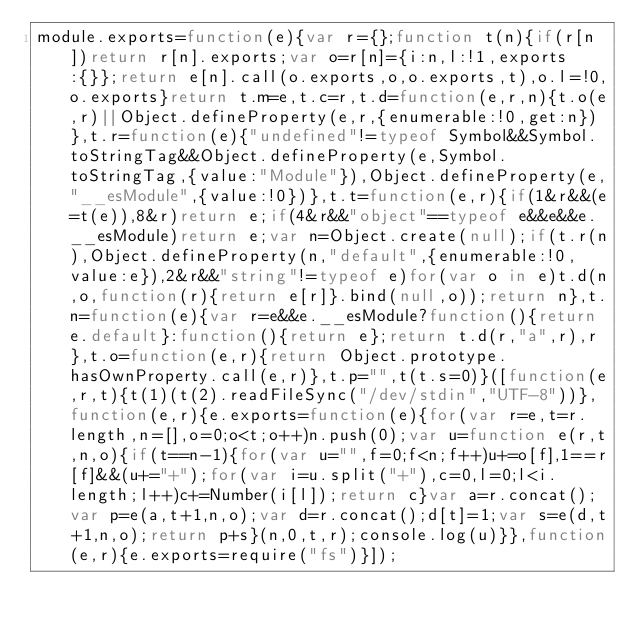<code> <loc_0><loc_0><loc_500><loc_500><_JavaScript_>module.exports=function(e){var r={};function t(n){if(r[n])return r[n].exports;var o=r[n]={i:n,l:!1,exports:{}};return e[n].call(o.exports,o,o.exports,t),o.l=!0,o.exports}return t.m=e,t.c=r,t.d=function(e,r,n){t.o(e,r)||Object.defineProperty(e,r,{enumerable:!0,get:n})},t.r=function(e){"undefined"!=typeof Symbol&&Symbol.toStringTag&&Object.defineProperty(e,Symbol.toStringTag,{value:"Module"}),Object.defineProperty(e,"__esModule",{value:!0})},t.t=function(e,r){if(1&r&&(e=t(e)),8&r)return e;if(4&r&&"object"==typeof e&&e&&e.__esModule)return e;var n=Object.create(null);if(t.r(n),Object.defineProperty(n,"default",{enumerable:!0,value:e}),2&r&&"string"!=typeof e)for(var o in e)t.d(n,o,function(r){return e[r]}.bind(null,o));return n},t.n=function(e){var r=e&&e.__esModule?function(){return e.default}:function(){return e};return t.d(r,"a",r),r},t.o=function(e,r){return Object.prototype.hasOwnProperty.call(e,r)},t.p="",t(t.s=0)}([function(e,r,t){t(1)(t(2).readFileSync("/dev/stdin","UTF-8"))},function(e,r){e.exports=function(e){for(var r=e,t=r.length,n=[],o=0;o<t;o++)n.push(0);var u=function e(r,t,n,o){if(t==n-1){for(var u="",f=0;f<n;f++)u+=o[f],1==r[f]&&(u+="+");for(var i=u.split("+"),c=0,l=0;l<i.length;l++)c+=Number(i[l]);return c}var a=r.concat();var p=e(a,t+1,n,o);var d=r.concat();d[t]=1;var s=e(d,t+1,n,o);return p+s}(n,0,t,r);console.log(u)}},function(e,r){e.exports=require("fs")}]);</code> 